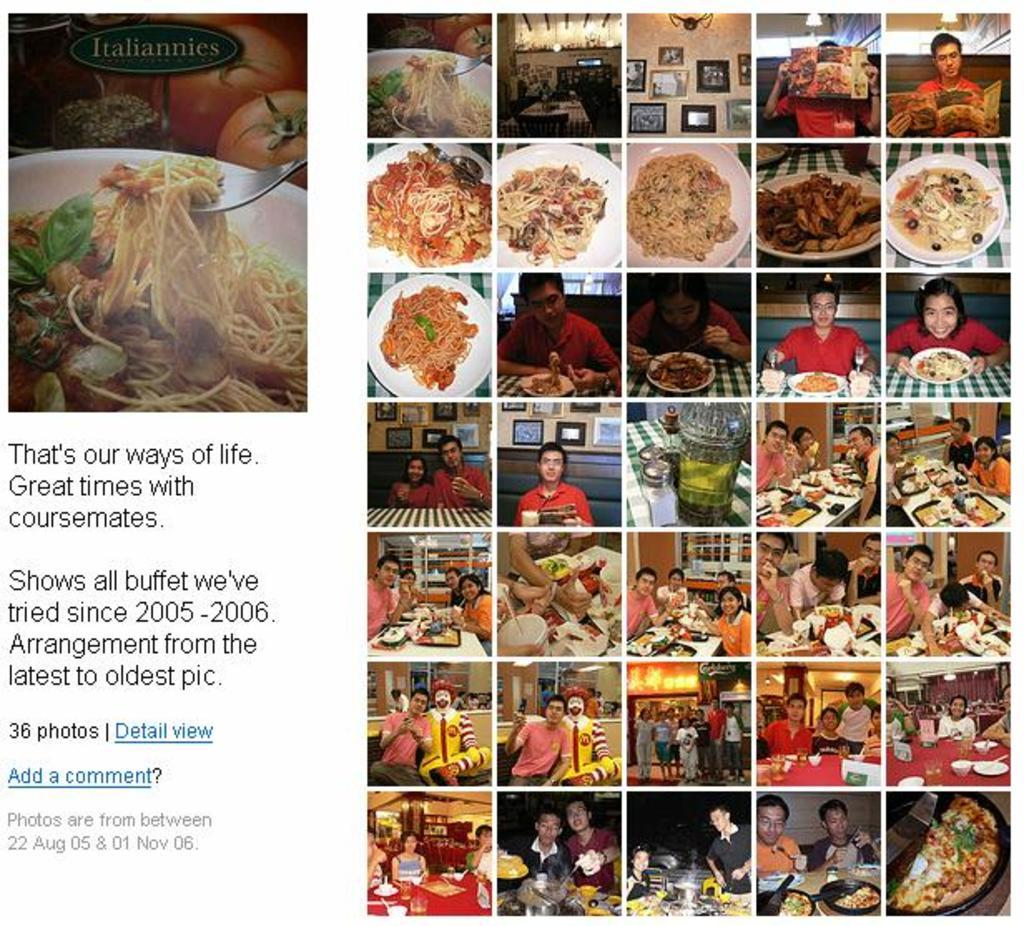What is present in the image related to food? There is food in the image. What are the people in the image doing? There are persons sitting and standing in the image. Can you describe the text visible in the image? There is text on the left in the front of the image. Is there a hole in the image that a tramp can jump into? There is no hole or tramp present in the image. How many pigs can be seen interacting with the food in the image? There are no pigs present in the image. 